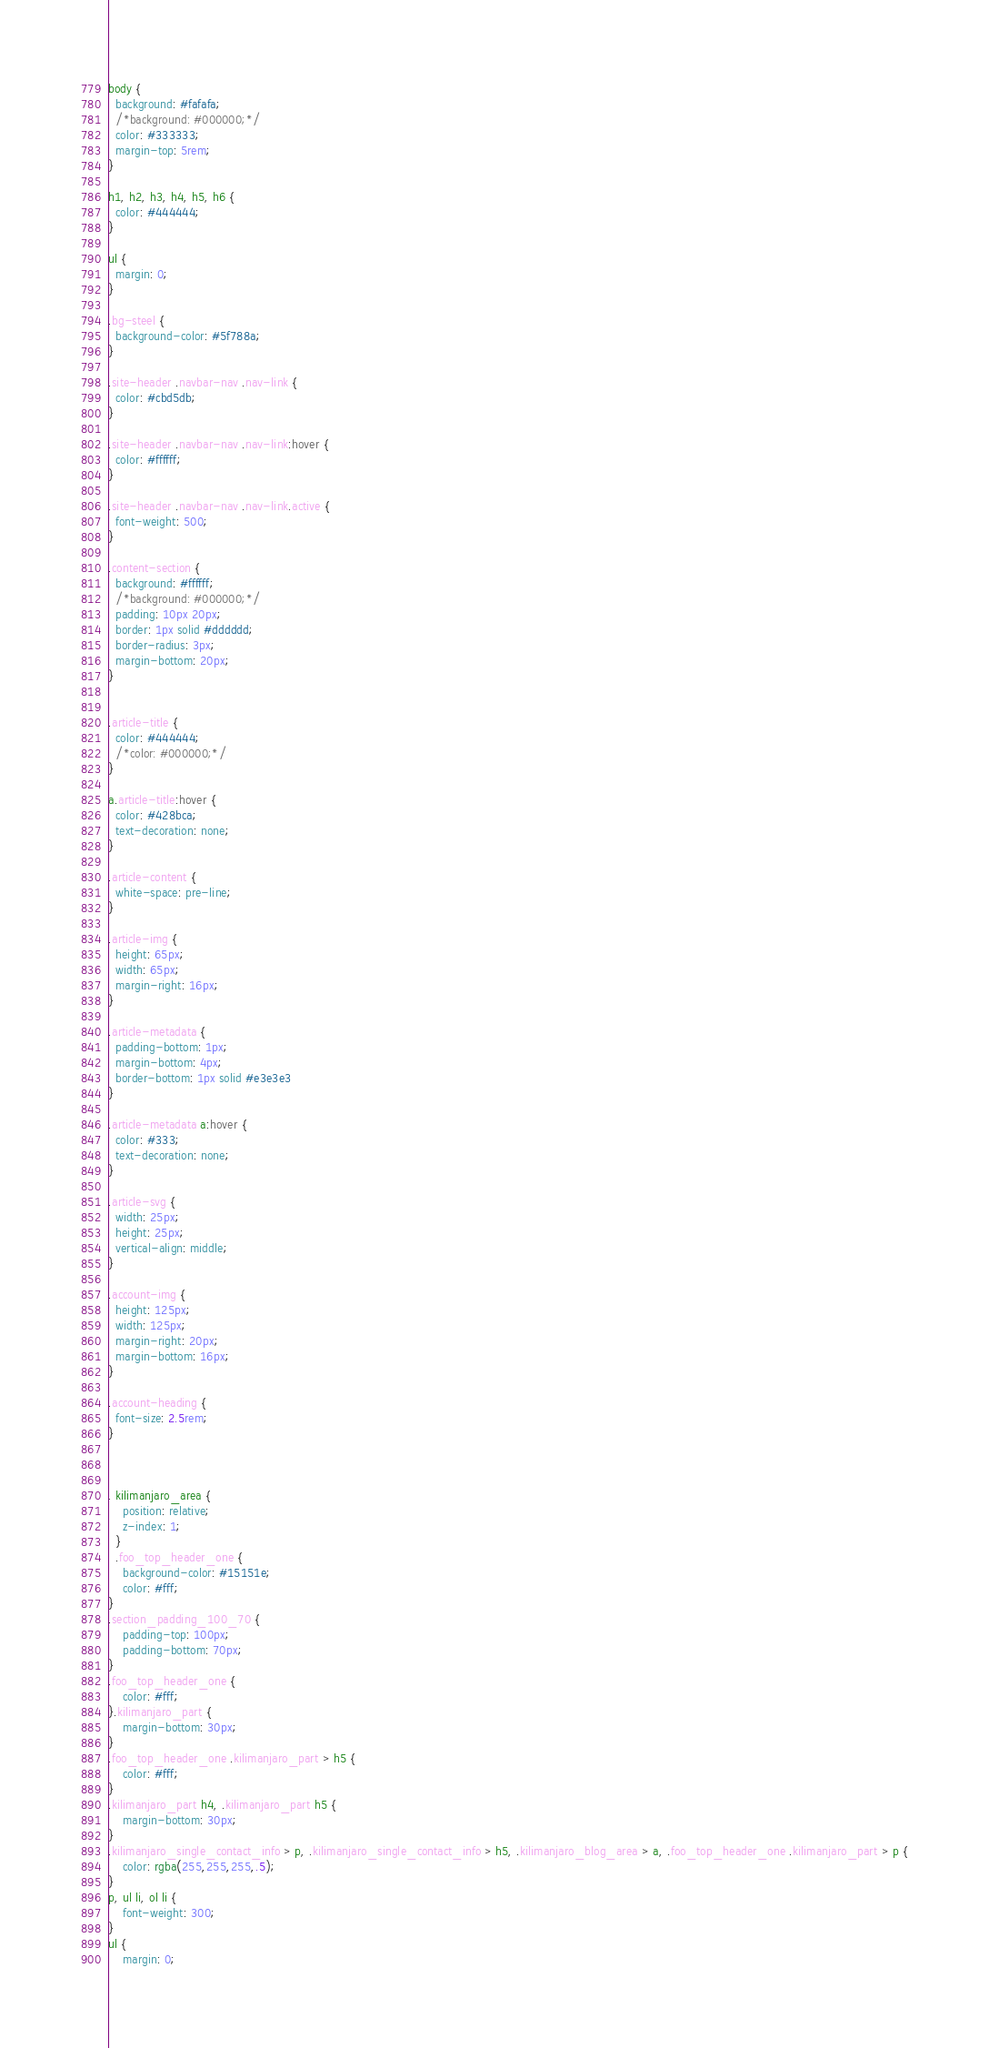Convert code to text. <code><loc_0><loc_0><loc_500><loc_500><_CSS_>body {
  background: #fafafa;
  /*background: #000000;*/
  color: #333333;
  margin-top: 5rem;
}

h1, h2, h3, h4, h5, h6 {
  color: #444444;
}

ul {
  margin: 0;
}

.bg-steel {
  background-color: #5f788a;
}

.site-header .navbar-nav .nav-link {
  color: #cbd5db;
}

.site-header .navbar-nav .nav-link:hover {
  color: #ffffff;
}

.site-header .navbar-nav .nav-link.active {
  font-weight: 500;
}

.content-section {
  background: #ffffff;
  /*background: #000000;*/
  padding: 10px 20px;
  border: 1px solid #dddddd;
  border-radius: 3px;
  margin-bottom: 20px;
}


.article-title {
  color: #444444;
  /*color: #000000;*/
}

a.article-title:hover {
  color: #428bca;
  text-decoration: none;
}

.article-content {
  white-space: pre-line;
}

.article-img {
  height: 65px;
  width: 65px;
  margin-right: 16px;
}

.article-metadata {
  padding-bottom: 1px;
  margin-bottom: 4px;
  border-bottom: 1px solid #e3e3e3
}

.article-metadata a:hover {
  color: #333;
  text-decoration: none;
}

.article-svg {
  width: 25px;
  height: 25px;
  vertical-align: middle;
}

.account-img {
  height: 125px;
  width: 125px;
  margin-right: 20px;
  margin-bottom: 16px;
}

.account-heading {
  font-size: 2.5rem;
}



. kilimanjaro_area {
    position: relative;
    z-index: 1;
  }
  .foo_top_header_one {
    background-color: #15151e;
    color: #fff;
}
.section_padding_100_70 {
    padding-top: 100px;
    padding-bottom: 70px;
}
.foo_top_header_one {
    color: #fff;
}.kilimanjaro_part {
    margin-bottom: 30px;
}
.foo_top_header_one .kilimanjaro_part > h5 {
    color: #fff;
}
.kilimanjaro_part h4, .kilimanjaro_part h5 {
    margin-bottom: 30px;
}
.kilimanjaro_single_contact_info > p, .kilimanjaro_single_contact_info > h5, .kilimanjaro_blog_area > a, .foo_top_header_one .kilimanjaro_part > p {
    color: rgba(255,255,255,.5);
}
p, ul li, ol li {
    font-weight: 300;
}
ul {
    margin: 0;</code> 